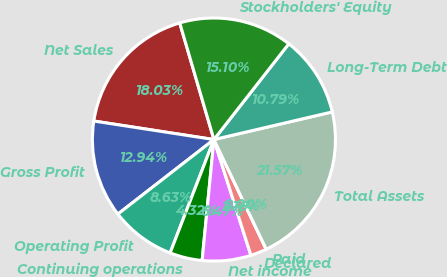Convert chart to OTSL. <chart><loc_0><loc_0><loc_500><loc_500><pie_chart><fcel>Net Sales<fcel>Gross Profit<fcel>Operating Profit<fcel>Continuing operations<fcel>Net income<fcel>Declared<fcel>Paid<fcel>Total Assets<fcel>Long-Term Debt<fcel>Stockholders' Equity<nl><fcel>18.03%<fcel>12.94%<fcel>8.63%<fcel>4.32%<fcel>6.47%<fcel>2.16%<fcel>0.0%<fcel>21.57%<fcel>10.79%<fcel>15.1%<nl></chart> 